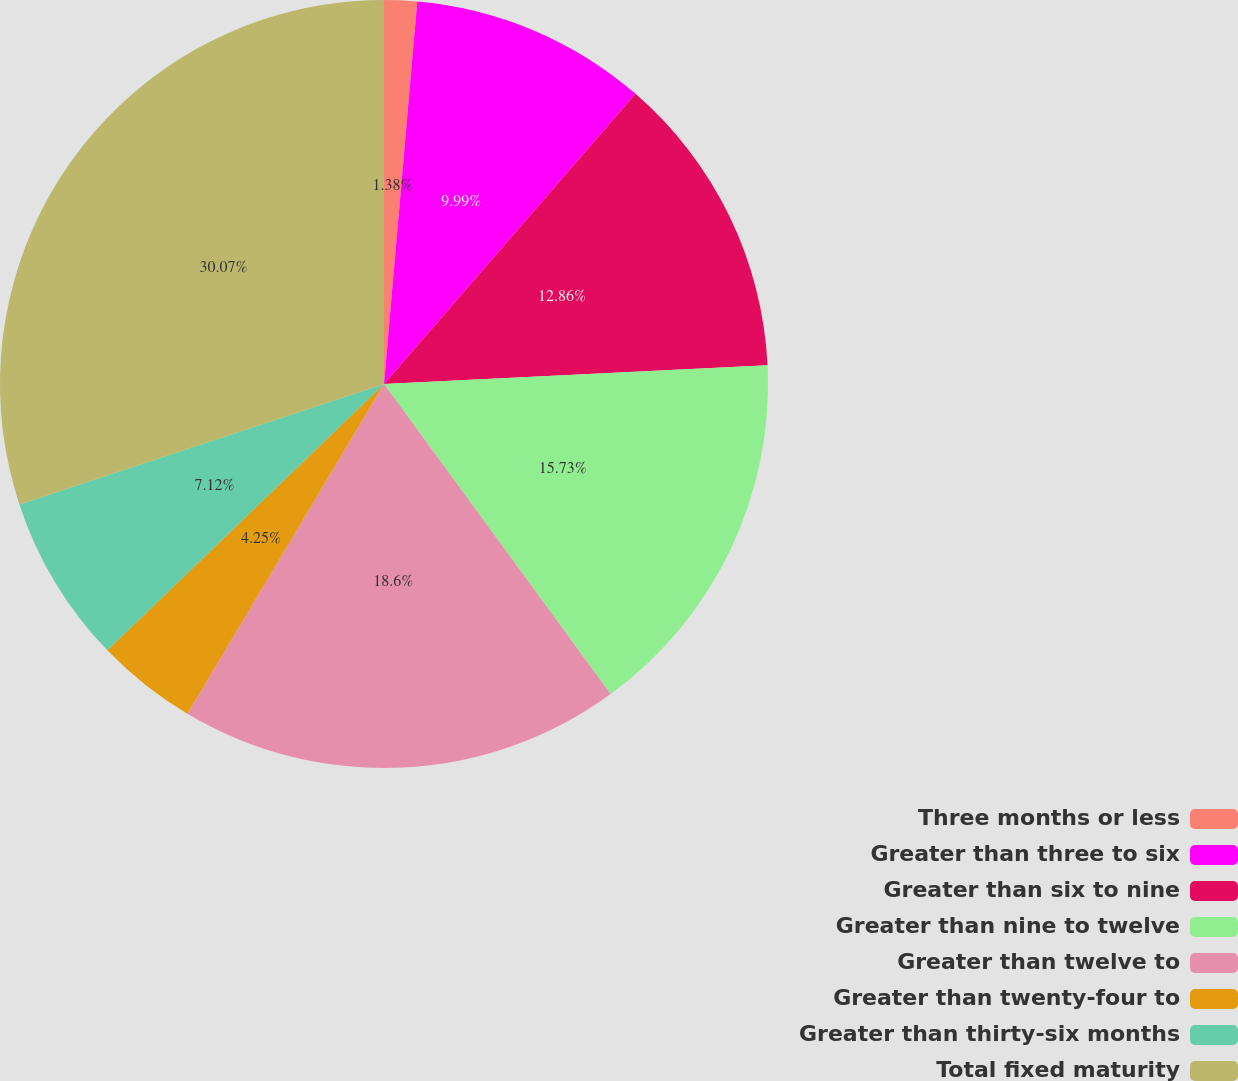Convert chart to OTSL. <chart><loc_0><loc_0><loc_500><loc_500><pie_chart><fcel>Three months or less<fcel>Greater than three to six<fcel>Greater than six to nine<fcel>Greater than nine to twelve<fcel>Greater than twelve to<fcel>Greater than twenty-four to<fcel>Greater than thirty-six months<fcel>Total fixed maturity<nl><fcel>1.38%<fcel>9.99%<fcel>12.86%<fcel>15.73%<fcel>18.6%<fcel>4.25%<fcel>7.12%<fcel>30.08%<nl></chart> 